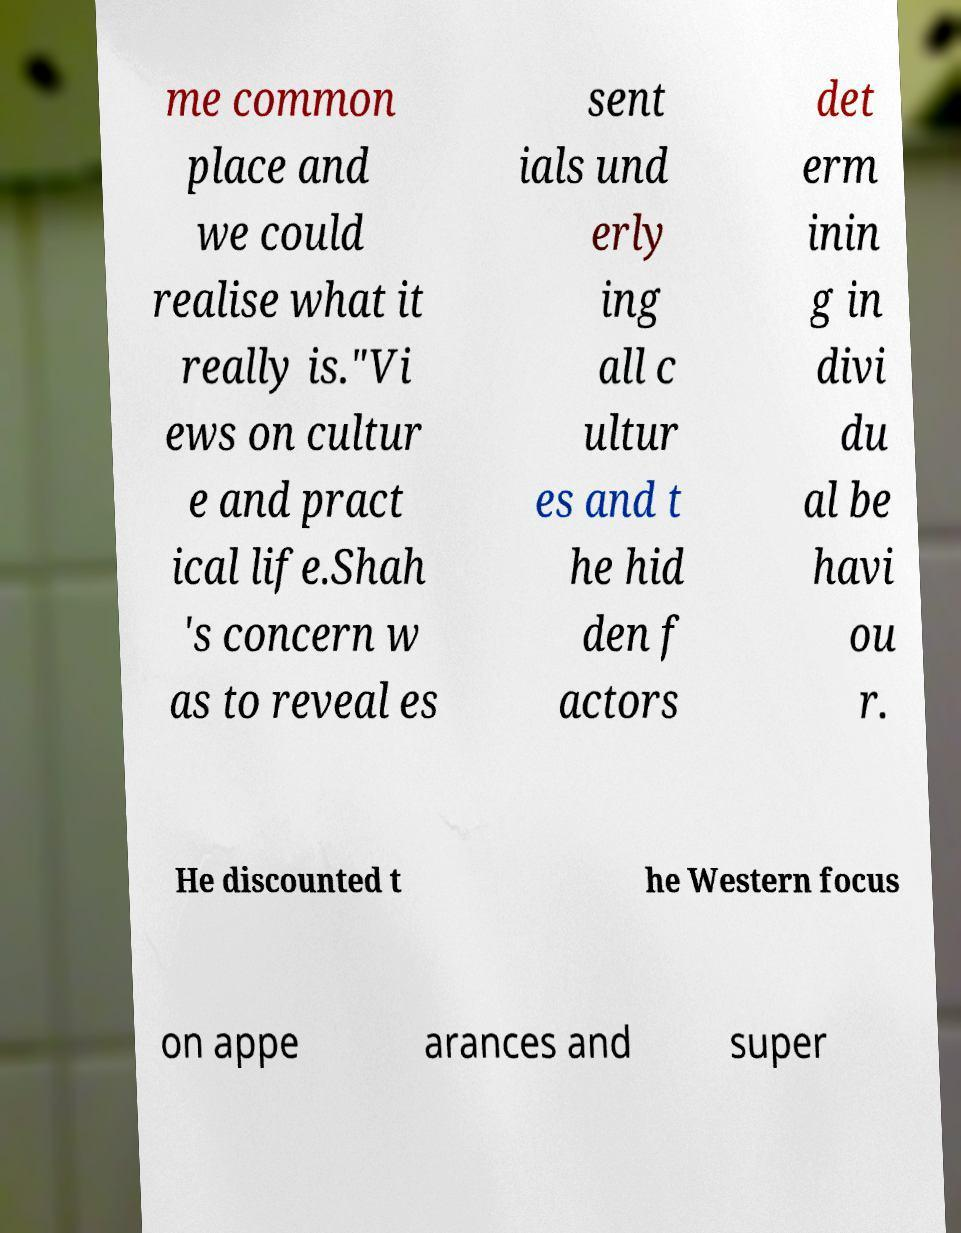There's text embedded in this image that I need extracted. Can you transcribe it verbatim? me common place and we could realise what it really is."Vi ews on cultur e and pract ical life.Shah 's concern w as to reveal es sent ials und erly ing all c ultur es and t he hid den f actors det erm inin g in divi du al be havi ou r. He discounted t he Western focus on appe arances and super 